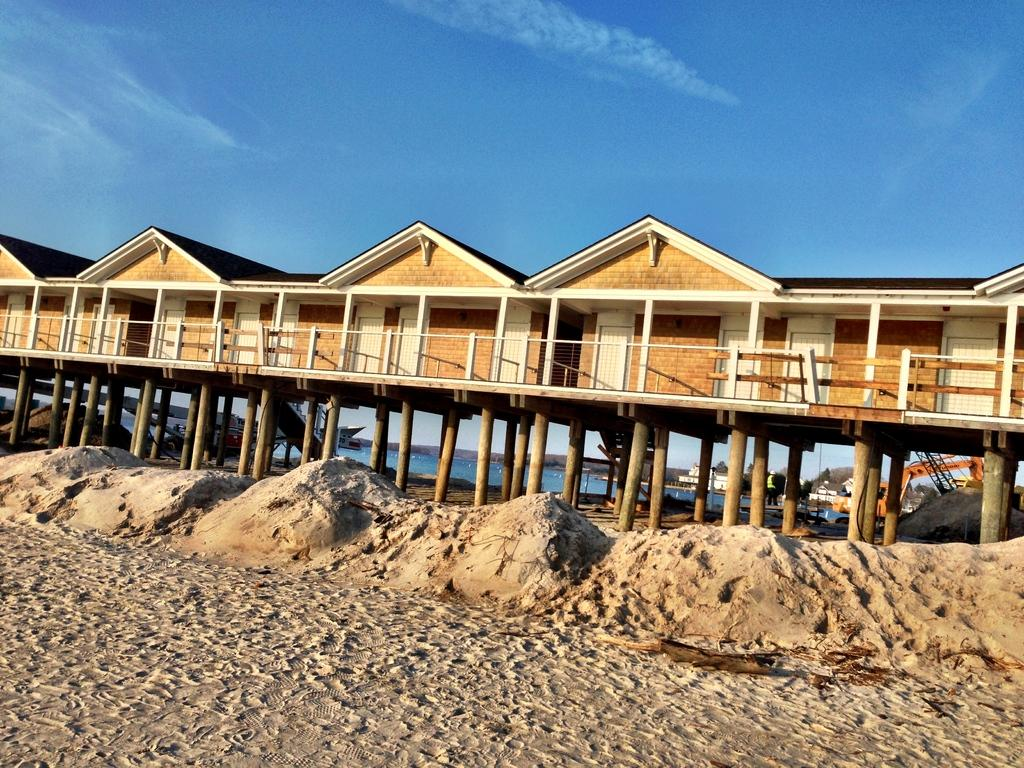What type of houses are in the image? There are wooden houses in the image. How are the wooden houses arranged? The wooden houses are arranged in rows. What type of terrain is visible in the image? There is sand visible in the image. What location is depicted in the image? There is a beach in the image. From where can the beach be seen in the image? The beach is visible from the pillars. Can you see a friend of yours in the image? There is no information about friends or any specific individuals in the image, so it cannot be determined if a friend is present. 